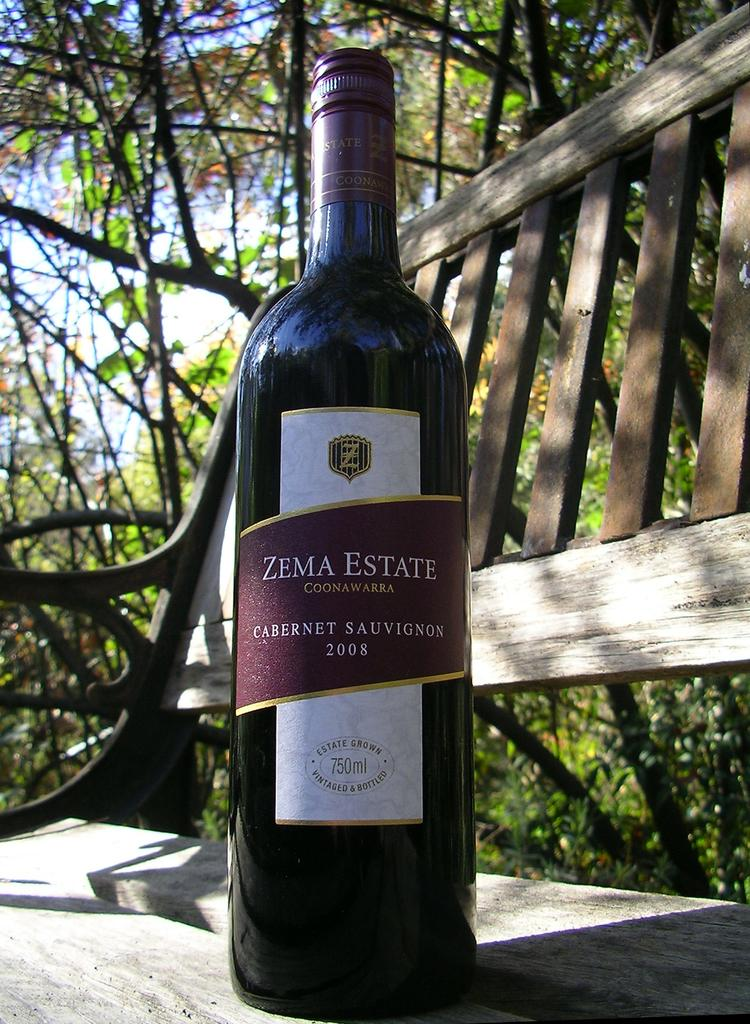<image>
Provide a brief description of the given image. A bottle of Zema Estate cabernet sauvignon 2008. 